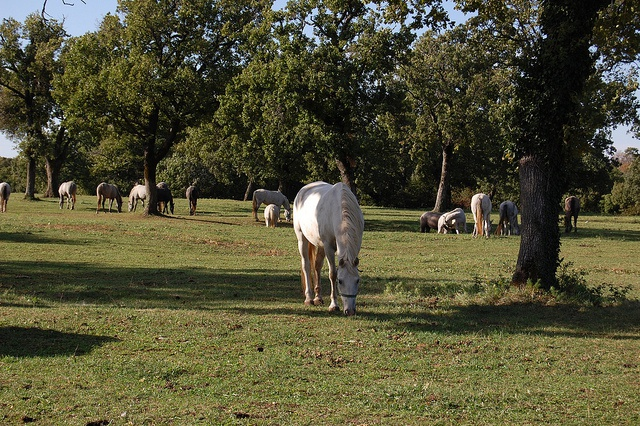Describe the objects in this image and their specific colors. I can see horse in lavender, gray, white, and black tones, horse in lavender, black, and gray tones, horse in lavender, gray, white, black, and darkgray tones, horse in lavender, black, gray, maroon, and darkgreen tones, and horse in lavender, black, lightgray, gray, and darkgray tones in this image. 